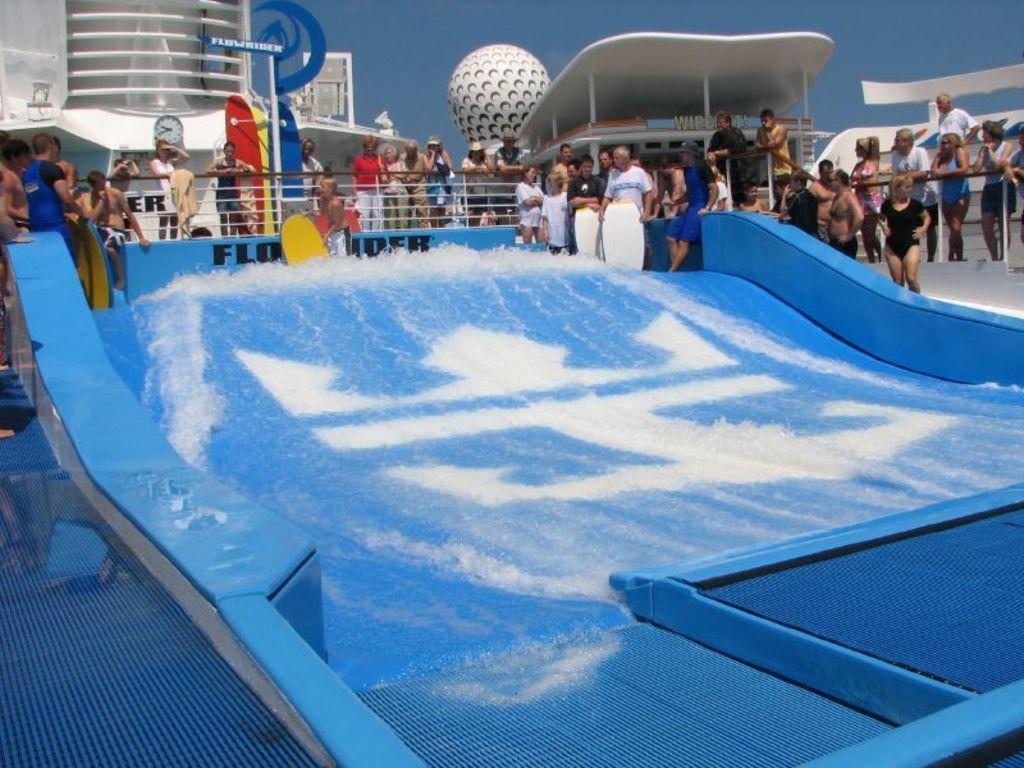Can you describe this image briefly? In this image in the background there are persons standing and there are objects which are white in colour. In the front there is water and there is an object which is blue in colour. 